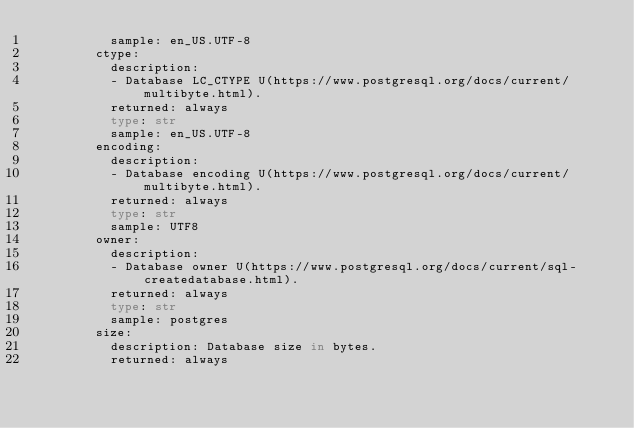<code> <loc_0><loc_0><loc_500><loc_500><_Python_>          sample: en_US.UTF-8
        ctype:
          description:
          - Database LC_CTYPE U(https://www.postgresql.org/docs/current/multibyte.html).
          returned: always
          type: str
          sample: en_US.UTF-8
        encoding:
          description:
          - Database encoding U(https://www.postgresql.org/docs/current/multibyte.html).
          returned: always
          type: str
          sample: UTF8
        owner:
          description:
          - Database owner U(https://www.postgresql.org/docs/current/sql-createdatabase.html).
          returned: always
          type: str
          sample: postgres
        size:
          description: Database size in bytes.
          returned: always</code> 